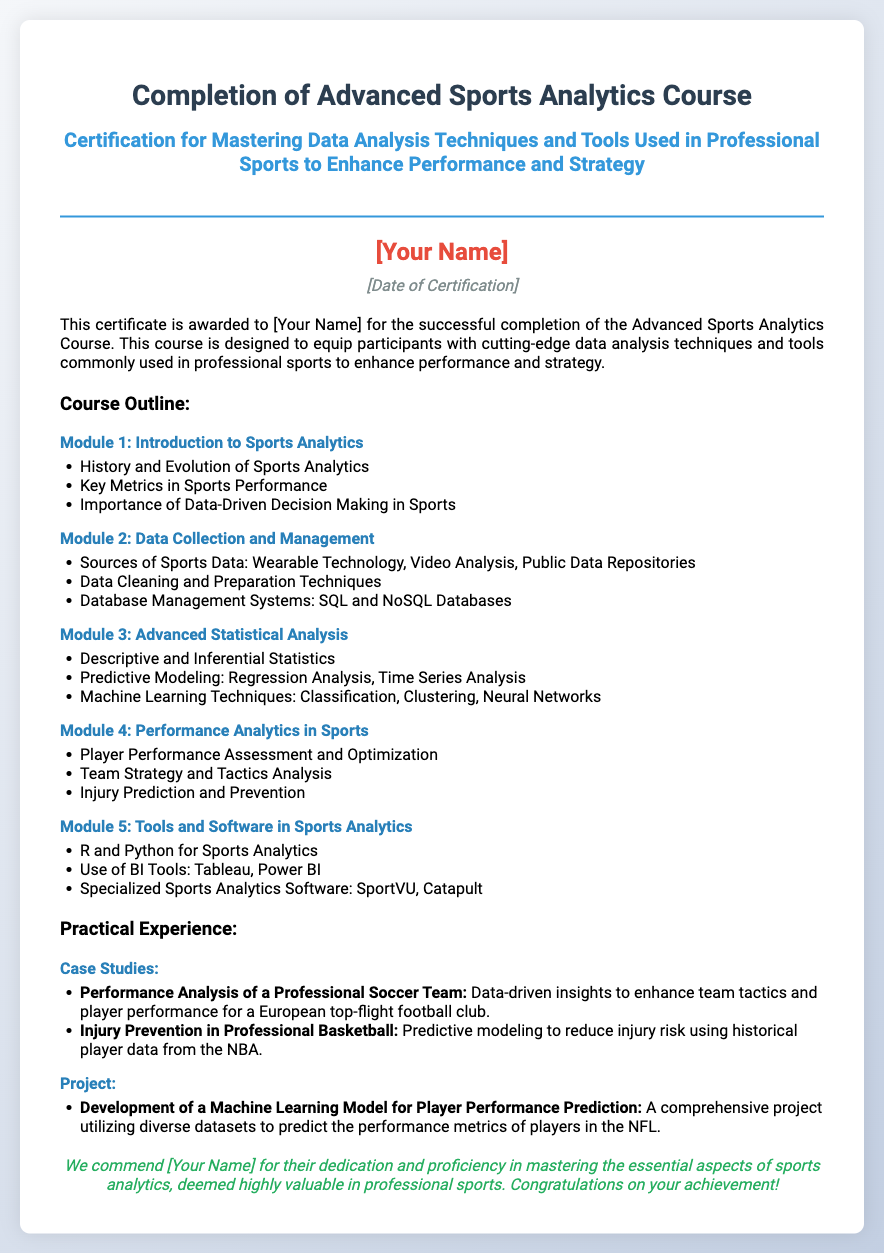What is the title of the certification? The title of the certification is prominently displayed at the top of the document, stating the purpose of the certificate.
Answer: Completion of Advanced Sports Analytics Course Who is the recipient of the certificate? The recipient's name is indicated in a styled font within the certificate and is a placeholder designating who achieved the certification.
Answer: [Your Name] What is the date of certification? The date is marked in a specific area of the certificate, serving to acknowledge when the certification was awarded.
Answer: [Date of Certification] How many modules are listed in the course outline? The number of modules can be counted from the course outline section, which lists each subject covered in the course.
Answer: 5 What technology is discussed in Module 2? This information is derived from the second module in the outline, which focuses on data-related topics in sports analytics.
Answer: Wearable Technology What type of project is mentioned in the practical experience section? The project type is specified in the practical experience section, which highlights the key learning application for participants.
Answer: Machine Learning Model for Player Performance Prediction What is one of the key topics in Module 4? One topic from the fourth module can be found under the performance analytics section, focusing on player assessment and strategy.
Answer: Player Performance Assessment and Optimization Which tools are mentioned in Module 5? The fifth module covers specific software tools used in sports analytics, which is a significant portion of the course content.
Answer: R and Python for Sports Analytics 